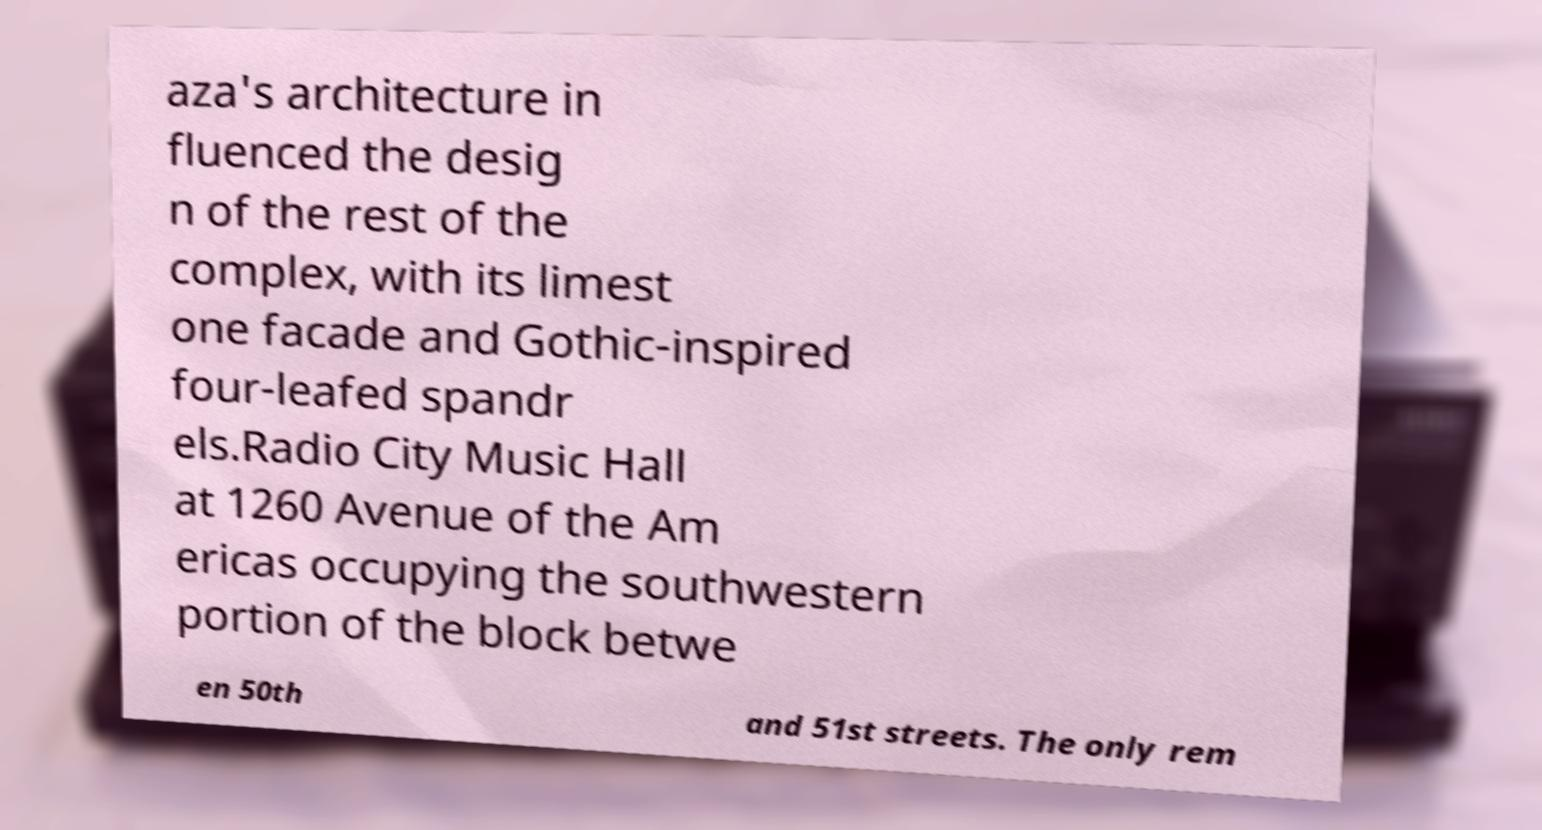Can you accurately transcribe the text from the provided image for me? aza's architecture in fluenced the desig n of the rest of the complex, with its limest one facade and Gothic-inspired four-leafed spandr els.Radio City Music Hall at 1260 Avenue of the Am ericas occupying the southwestern portion of the block betwe en 50th and 51st streets. The only rem 